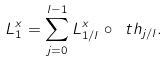<formula> <loc_0><loc_0><loc_500><loc_500>L ^ { x } _ { 1 } = \sum _ { j = 0 } ^ { l - 1 } L ^ { x } _ { 1 / l } \circ \ t h _ { j / l } .</formula> 